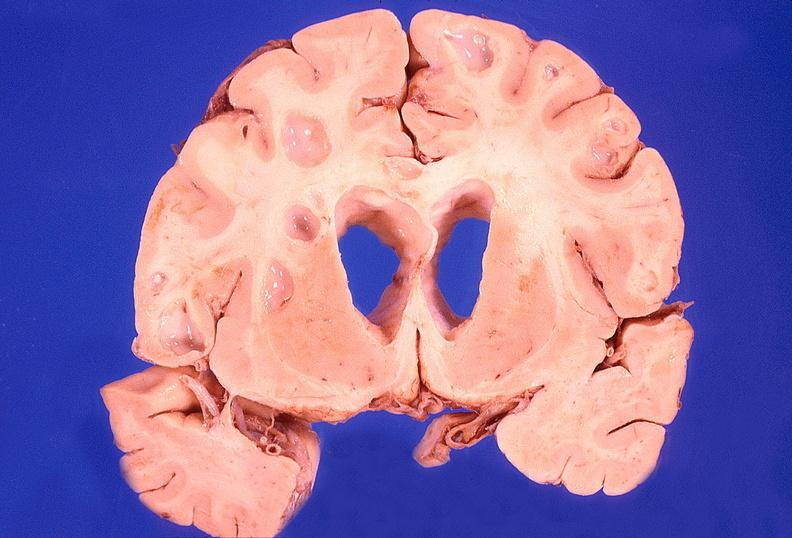does this image show brain abscess?
Answer the question using a single word or phrase. Yes 